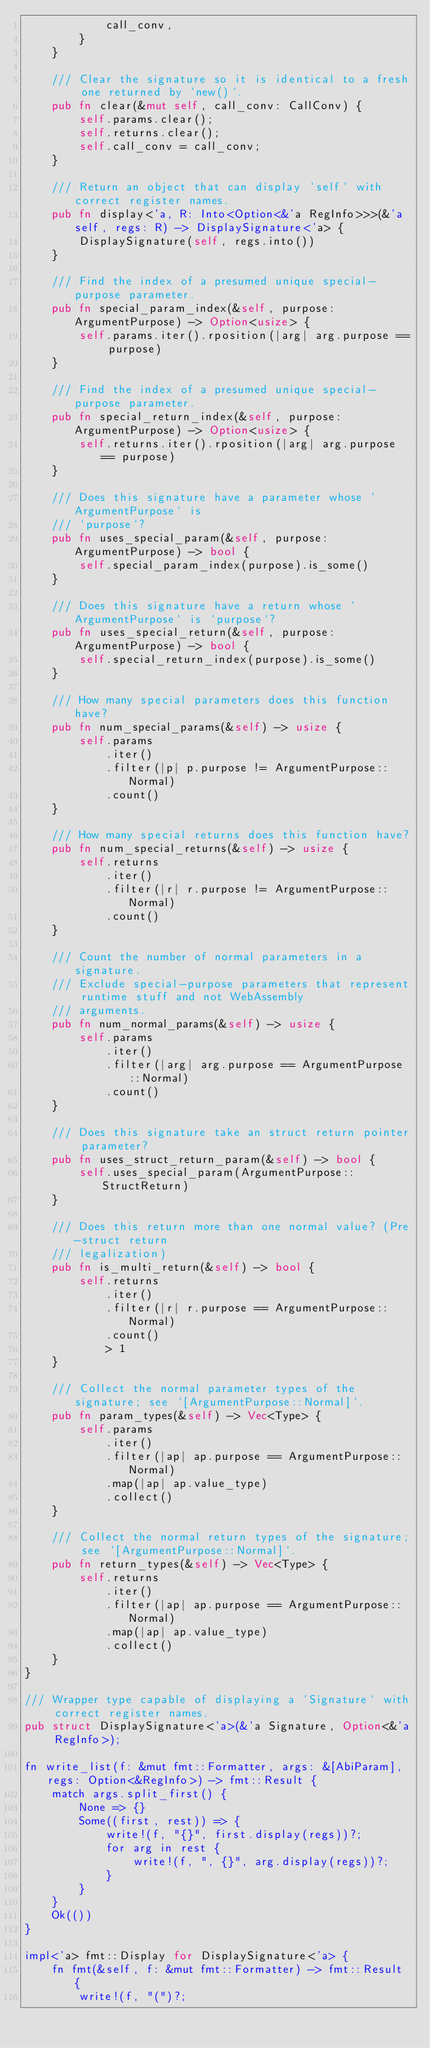<code> <loc_0><loc_0><loc_500><loc_500><_Rust_>            call_conv,
        }
    }

    /// Clear the signature so it is identical to a fresh one returned by `new()`.
    pub fn clear(&mut self, call_conv: CallConv) {
        self.params.clear();
        self.returns.clear();
        self.call_conv = call_conv;
    }

    /// Return an object that can display `self` with correct register names.
    pub fn display<'a, R: Into<Option<&'a RegInfo>>>(&'a self, regs: R) -> DisplaySignature<'a> {
        DisplaySignature(self, regs.into())
    }

    /// Find the index of a presumed unique special-purpose parameter.
    pub fn special_param_index(&self, purpose: ArgumentPurpose) -> Option<usize> {
        self.params.iter().rposition(|arg| arg.purpose == purpose)
    }

    /// Find the index of a presumed unique special-purpose parameter.
    pub fn special_return_index(&self, purpose: ArgumentPurpose) -> Option<usize> {
        self.returns.iter().rposition(|arg| arg.purpose == purpose)
    }

    /// Does this signature have a parameter whose `ArgumentPurpose` is
    /// `purpose`?
    pub fn uses_special_param(&self, purpose: ArgumentPurpose) -> bool {
        self.special_param_index(purpose).is_some()
    }

    /// Does this signature have a return whose `ArgumentPurpose` is `purpose`?
    pub fn uses_special_return(&self, purpose: ArgumentPurpose) -> bool {
        self.special_return_index(purpose).is_some()
    }

    /// How many special parameters does this function have?
    pub fn num_special_params(&self) -> usize {
        self.params
            .iter()
            .filter(|p| p.purpose != ArgumentPurpose::Normal)
            .count()
    }

    /// How many special returns does this function have?
    pub fn num_special_returns(&self) -> usize {
        self.returns
            .iter()
            .filter(|r| r.purpose != ArgumentPurpose::Normal)
            .count()
    }

    /// Count the number of normal parameters in a signature.
    /// Exclude special-purpose parameters that represent runtime stuff and not WebAssembly
    /// arguments.
    pub fn num_normal_params(&self) -> usize {
        self.params
            .iter()
            .filter(|arg| arg.purpose == ArgumentPurpose::Normal)
            .count()
    }

    /// Does this signature take an struct return pointer parameter?
    pub fn uses_struct_return_param(&self) -> bool {
        self.uses_special_param(ArgumentPurpose::StructReturn)
    }

    /// Does this return more than one normal value? (Pre-struct return
    /// legalization)
    pub fn is_multi_return(&self) -> bool {
        self.returns
            .iter()
            .filter(|r| r.purpose == ArgumentPurpose::Normal)
            .count()
            > 1
    }

    /// Collect the normal parameter types of the signature; see `[ArgumentPurpose::Normal]`.
    pub fn param_types(&self) -> Vec<Type> {
        self.params
            .iter()
            .filter(|ap| ap.purpose == ArgumentPurpose::Normal)
            .map(|ap| ap.value_type)
            .collect()
    }

    /// Collect the normal return types of the signature; see `[ArgumentPurpose::Normal]`.
    pub fn return_types(&self) -> Vec<Type> {
        self.returns
            .iter()
            .filter(|ap| ap.purpose == ArgumentPurpose::Normal)
            .map(|ap| ap.value_type)
            .collect()
    }
}

/// Wrapper type capable of displaying a `Signature` with correct register names.
pub struct DisplaySignature<'a>(&'a Signature, Option<&'a RegInfo>);

fn write_list(f: &mut fmt::Formatter, args: &[AbiParam], regs: Option<&RegInfo>) -> fmt::Result {
    match args.split_first() {
        None => {}
        Some((first, rest)) => {
            write!(f, "{}", first.display(regs))?;
            for arg in rest {
                write!(f, ", {}", arg.display(regs))?;
            }
        }
    }
    Ok(())
}

impl<'a> fmt::Display for DisplaySignature<'a> {
    fn fmt(&self, f: &mut fmt::Formatter) -> fmt::Result {
        write!(f, "(")?;</code> 